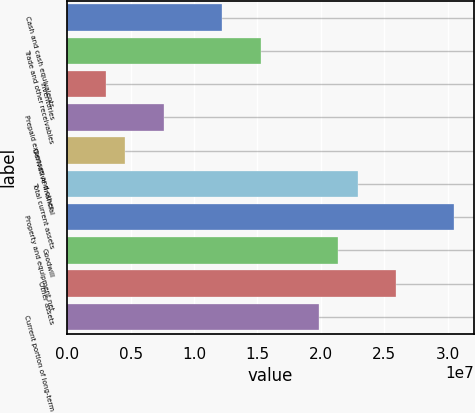<chart> <loc_0><loc_0><loc_500><loc_500><bar_chart><fcel>Cash and cash equivalents<fcel>Trade and other receivables<fcel>Inventories<fcel>Prepaid expenses and other<fcel>Derivative financial<fcel>Total current assets<fcel>Property and equipment net<fcel>Goodwill<fcel>Other assets<fcel>Current portion of long-term<nl><fcel>1.22149e+07<fcel>1.52681e+07<fcel>3.0554e+06<fcel>7.63515e+06<fcel>4.58199e+06<fcel>2.2901e+07<fcel>3.05339e+07<fcel>2.13744e+07<fcel>2.59541e+07<fcel>1.98478e+07<nl></chart> 